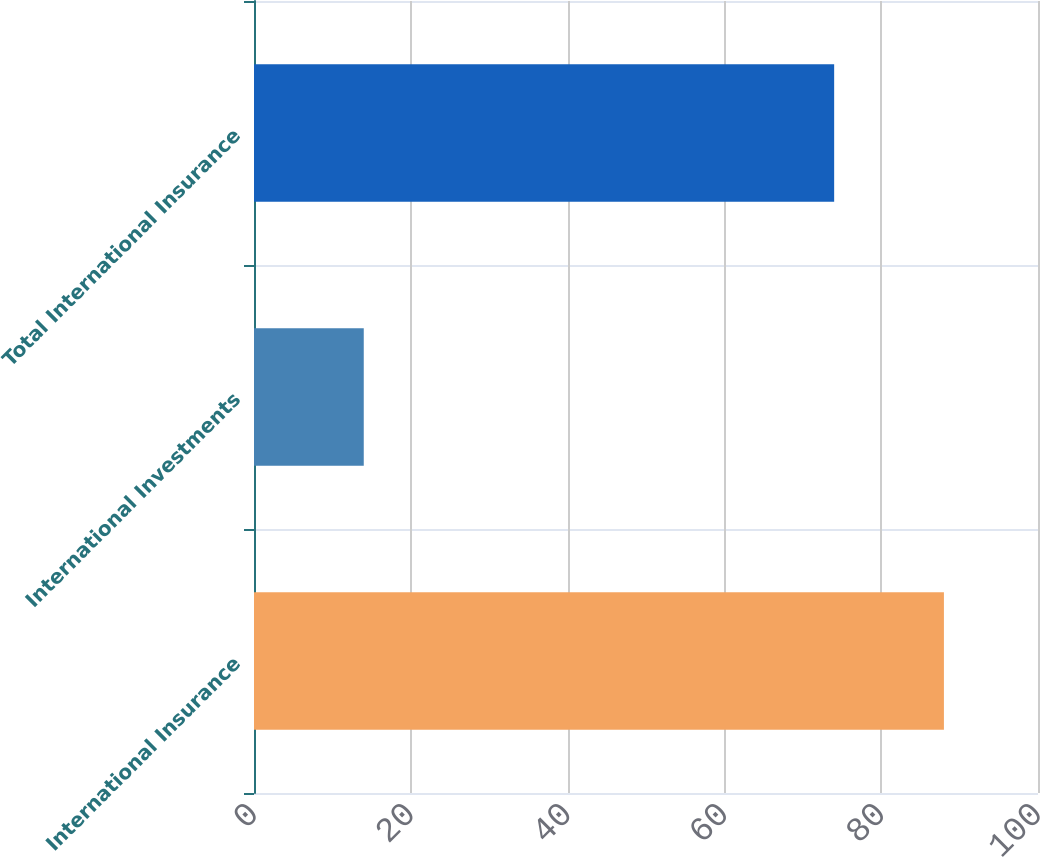Convert chart to OTSL. <chart><loc_0><loc_0><loc_500><loc_500><bar_chart><fcel>International Insurance<fcel>International Investments<fcel>Total International Insurance<nl><fcel>88<fcel>14<fcel>74<nl></chart> 